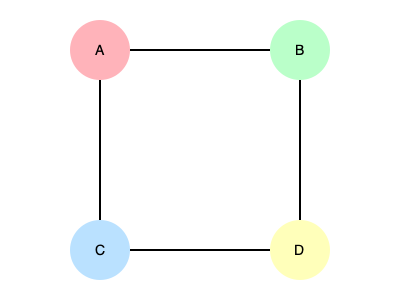In the given network diagram representing gene flow between four populations (A, B, C, and D), which population appears to be the most isolated based on the pattern and frequency of gene flow? To determine the most isolated population, we need to analyze the gene flow patterns represented by the animated lines between populations:

1. Observe the connections:
   - A is connected to B and C
   - B is connected to A and D
   - C is connected to A and D
   - D is connected to B and C

2. Analyze the animation speeds:
   - A-B: Medium speed (4s)
   - A-C: Fast speed (2s)
   - C-D: Slow speed (6s)
   - B-D: Medium-fast speed (3s)

3. Interpret the animation speeds:
   - Faster animations indicate more frequent gene flow
   - Slower animations indicate less frequent gene flow

4. Compare the connections and gene flow frequencies:
   - A has two connections with medium and fast gene flow
   - B has two connections with medium and medium-fast gene flow
   - C has two connections with fast and slow gene flow
   - D has two connections with slow and medium-fast gene flow

5. Conclusion:
   Population D appears to be the most isolated because:
   - It has the slowest gene flow connection (with C)
   - Its faster connection (with B) is still slower than the fastest connections in the network
   - It lacks any direct connection to population A, which seems to have the most active gene flow
Answer: Population D 